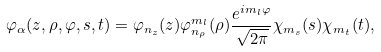Convert formula to latex. <formula><loc_0><loc_0><loc_500><loc_500>\varphi _ { \alpha } ( z , \rho , \varphi , s , t ) = \varphi _ { n _ { z } } ( z ) \varphi _ { n _ { \rho } } ^ { m _ { l } } ( \rho ) \frac { e ^ { i m _ { l } \varphi } } { \sqrt { 2 \pi } } \chi _ { m _ { s } } ( s ) \chi _ { m _ { t } } ( t ) ,</formula> 